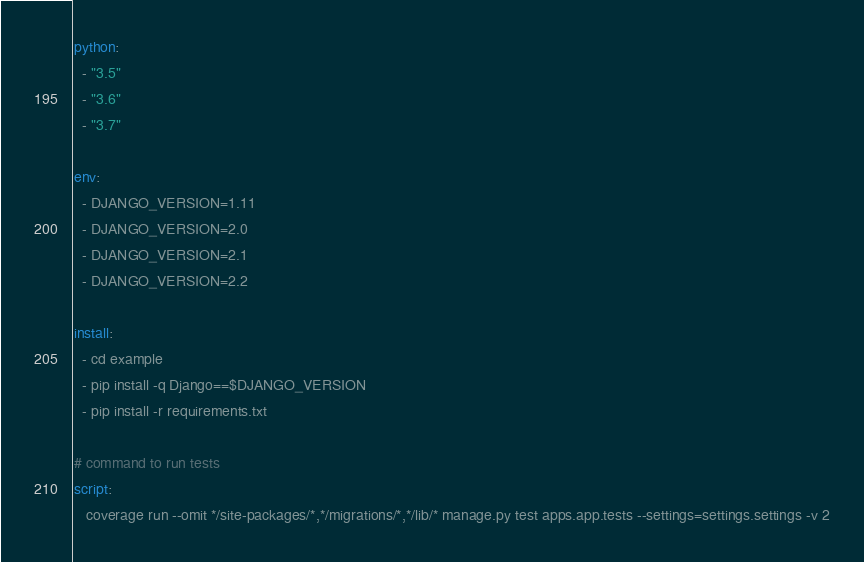<code> <loc_0><loc_0><loc_500><loc_500><_YAML_>python:
  - "3.5"
  - "3.6"
  - "3.7"

env:
  - DJANGO_VERSION=1.11
  - DJANGO_VERSION=2.0
  - DJANGO_VERSION=2.1
  - DJANGO_VERSION=2.2

install:
  - cd example
  - pip install -q Django==$DJANGO_VERSION
  - pip install -r requirements.txt

# command to run tests
script:
   coverage run --omit */site-packages/*,*/migrations/*,*/lib/* manage.py test apps.app.tests --settings=settings.settings -v 2
</code> 